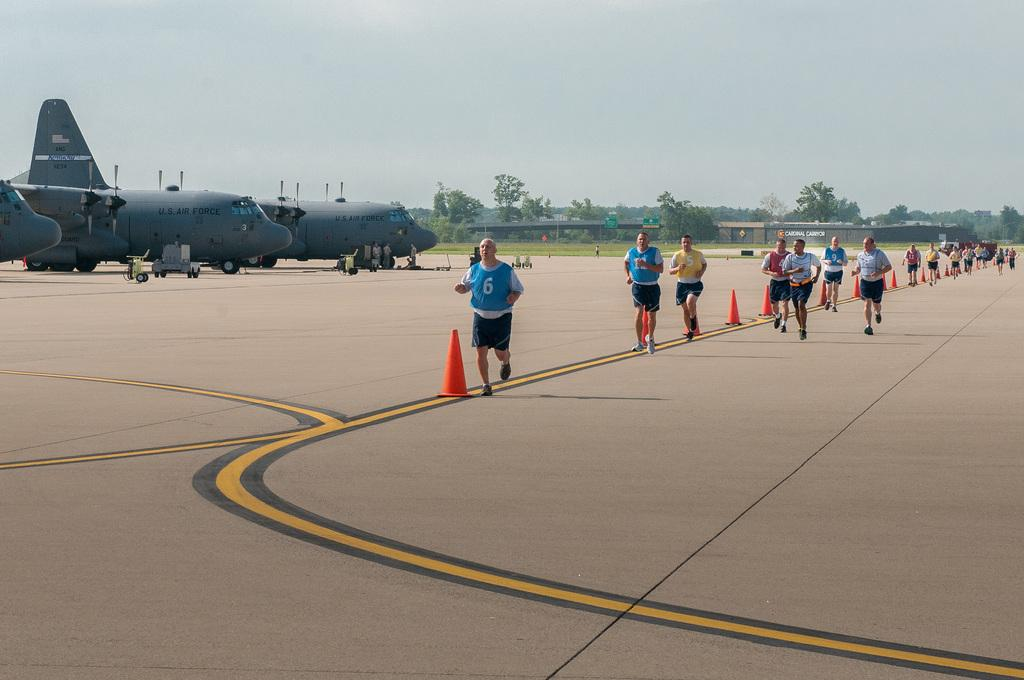<image>
Render a clear and concise summary of the photo. People run on the runway that sits planes labeled as US Air Force. 